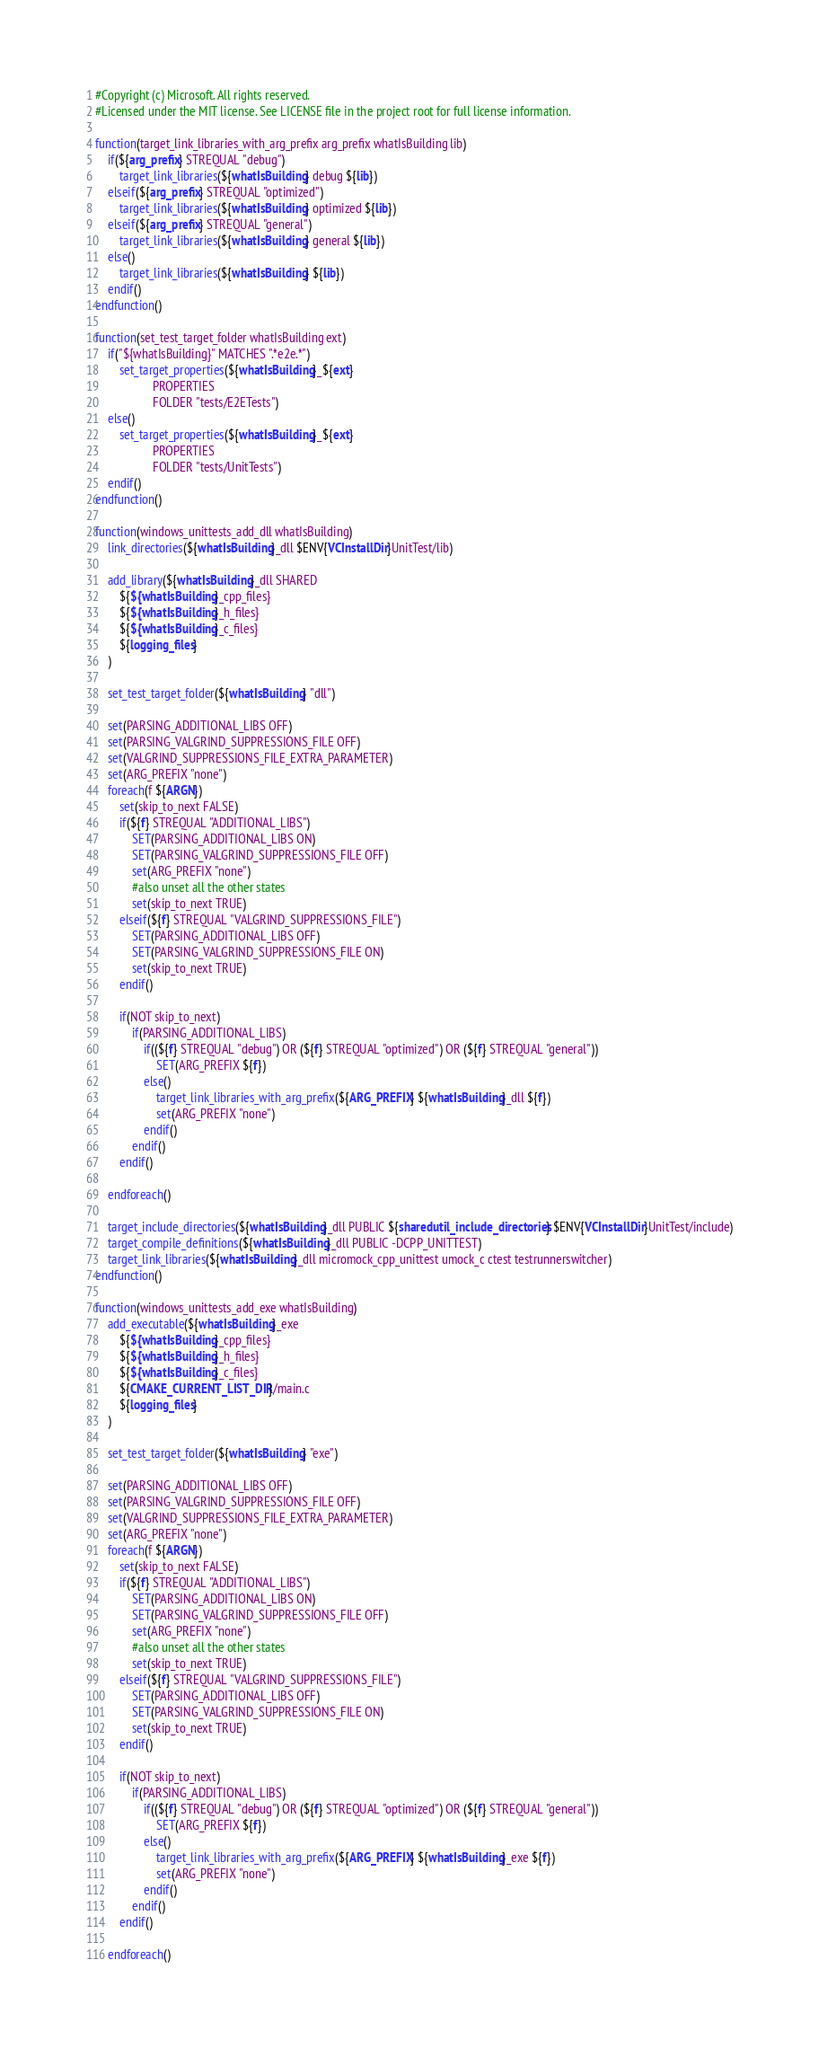<code> <loc_0><loc_0><loc_500><loc_500><_CMake_>#Copyright (c) Microsoft. All rights reserved.
#Licensed under the MIT license. See LICENSE file in the project root for full license information.

function(target_link_libraries_with_arg_prefix arg_prefix whatIsBuilding lib)
    if(${arg_prefix} STREQUAL "debug")
        target_link_libraries(${whatIsBuilding} debug ${lib})
    elseif(${arg_prefix} STREQUAL "optimized")
        target_link_libraries(${whatIsBuilding} optimized ${lib})
    elseif(${arg_prefix} STREQUAL "general")
        target_link_libraries(${whatIsBuilding} general ${lib})
    else()
        target_link_libraries(${whatIsBuilding} ${lib})
    endif()
endfunction()

function(set_test_target_folder whatIsBuilding ext)
    if("${whatIsBuilding}" MATCHES ".*e2e.*")
        set_target_properties(${whatIsBuilding}_${ext}
                   PROPERTIES
                   FOLDER "tests/E2ETests")
    else()
        set_target_properties(${whatIsBuilding}_${ext}
                   PROPERTIES
                   FOLDER "tests/UnitTests")
    endif()
endfunction()

function(windows_unittests_add_dll whatIsBuilding)
    link_directories(${whatIsBuilding}_dll $ENV{VCInstallDir}UnitTest/lib)

    add_library(${whatIsBuilding}_dll SHARED
        ${${whatIsBuilding}_cpp_files}
        ${${whatIsBuilding}_h_files}
        ${${whatIsBuilding}_c_files}
        ${logging_files}
    )

    set_test_target_folder(${whatIsBuilding} "dll")

    set(PARSING_ADDITIONAL_LIBS OFF)
    set(PARSING_VALGRIND_SUPPRESSIONS_FILE OFF)
    set(VALGRIND_SUPPRESSIONS_FILE_EXTRA_PARAMETER)
    set(ARG_PREFIX "none")
    foreach(f ${ARGN})
        set(skip_to_next FALSE)
        if(${f} STREQUAL "ADDITIONAL_LIBS")
            SET(PARSING_ADDITIONAL_LIBS ON)
            SET(PARSING_VALGRIND_SUPPRESSIONS_FILE OFF)
            set(ARG_PREFIX "none")
            #also unset all the other states
            set(skip_to_next TRUE)
        elseif(${f} STREQUAL "VALGRIND_SUPPRESSIONS_FILE")
            SET(PARSING_ADDITIONAL_LIBS OFF)
            SET(PARSING_VALGRIND_SUPPRESSIONS_FILE ON)
            set(skip_to_next TRUE)
        endif()

        if(NOT skip_to_next)
            if(PARSING_ADDITIONAL_LIBS)
                if((${f} STREQUAL "debug") OR (${f} STREQUAL "optimized") OR (${f} STREQUAL "general"))
                    SET(ARG_PREFIX ${f})
                else()
                    target_link_libraries_with_arg_prefix(${ARG_PREFIX} ${whatIsBuilding}_dll ${f})
                    set(ARG_PREFIX "none")
                endif()
            endif()
        endif()

    endforeach()

    target_include_directories(${whatIsBuilding}_dll PUBLIC ${sharedutil_include_directories} $ENV{VCInstallDir}UnitTest/include)
    target_compile_definitions(${whatIsBuilding}_dll PUBLIC -DCPP_UNITTEST)
    target_link_libraries(${whatIsBuilding}_dll micromock_cpp_unittest umock_c ctest testrunnerswitcher)
endfunction()

function(windows_unittests_add_exe whatIsBuilding)
    add_executable(${whatIsBuilding}_exe
        ${${whatIsBuilding}_cpp_files}
        ${${whatIsBuilding}_h_files}
        ${${whatIsBuilding}_c_files}
        ${CMAKE_CURRENT_LIST_DIR}/main.c
        ${logging_files}
    )

    set_test_target_folder(${whatIsBuilding} "exe")

    set(PARSING_ADDITIONAL_LIBS OFF)
    set(PARSING_VALGRIND_SUPPRESSIONS_FILE OFF)
    set(VALGRIND_SUPPRESSIONS_FILE_EXTRA_PARAMETER)
    set(ARG_PREFIX "none")
    foreach(f ${ARGN})
        set(skip_to_next FALSE)
        if(${f} STREQUAL "ADDITIONAL_LIBS")
            SET(PARSING_ADDITIONAL_LIBS ON)
            SET(PARSING_VALGRIND_SUPPRESSIONS_FILE OFF)
            set(ARG_PREFIX "none")
            #also unset all the other states
            set(skip_to_next TRUE)
        elseif(${f} STREQUAL "VALGRIND_SUPPRESSIONS_FILE")
            SET(PARSING_ADDITIONAL_LIBS OFF)
            SET(PARSING_VALGRIND_SUPPRESSIONS_FILE ON)
            set(skip_to_next TRUE)
        endif()

        if(NOT skip_to_next)
            if(PARSING_ADDITIONAL_LIBS)
                if((${f} STREQUAL "debug") OR (${f} STREQUAL "optimized") OR (${f} STREQUAL "general"))
                    SET(ARG_PREFIX ${f})
                else()
                    target_link_libraries_with_arg_prefix(${ARG_PREFIX} ${whatIsBuilding}_exe ${f})
                    set(ARG_PREFIX "none")
                endif()
            endif()
        endif()

    endforeach()
</code> 